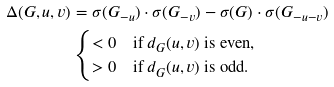Convert formula to latex. <formula><loc_0><loc_0><loc_500><loc_500>\Delta ( G , u , v ) & = \sigma ( G _ { - u } ) \cdot \sigma ( G _ { - v } ) - \sigma ( G ) \cdot \sigma ( G _ { - u - v } ) \\ & \begin{cases} < 0 & \text {if } d _ { G } ( u , v ) \text { is even,} \\ > 0 & \text {if } d _ { G } ( u , v ) \text { is odd.} \end{cases}</formula> 